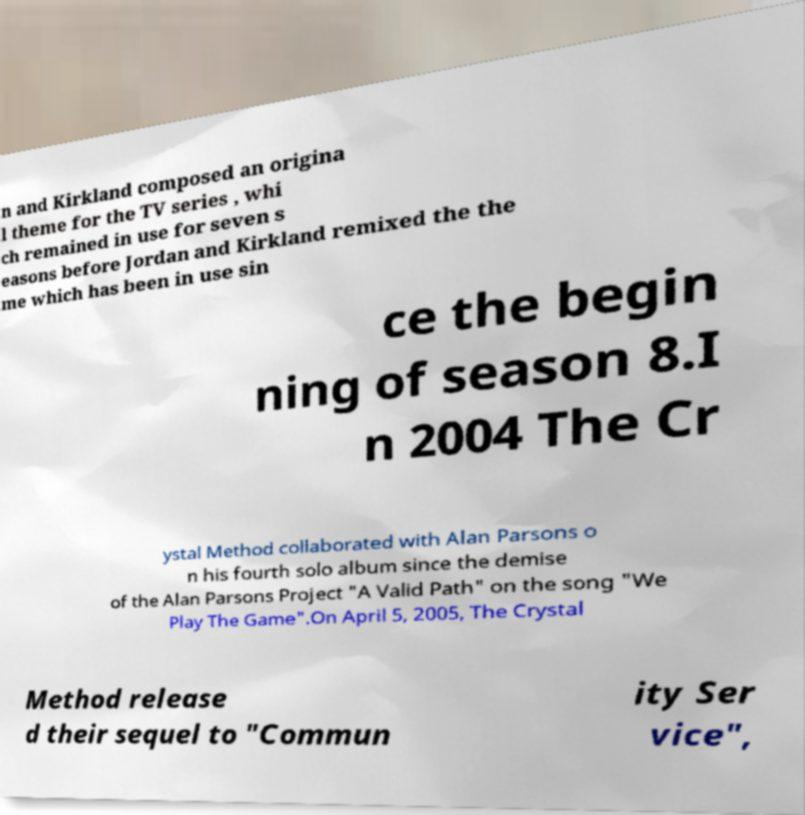I need the written content from this picture converted into text. Can you do that? n and Kirkland composed an origina l theme for the TV series , whi ch remained in use for seven s easons before Jordan and Kirkland remixed the the me which has been in use sin ce the begin ning of season 8.I n 2004 The Cr ystal Method collaborated with Alan Parsons o n his fourth solo album since the demise of the Alan Parsons Project "A Valid Path" on the song "We Play The Game".On April 5, 2005, The Crystal Method release d their sequel to "Commun ity Ser vice", 